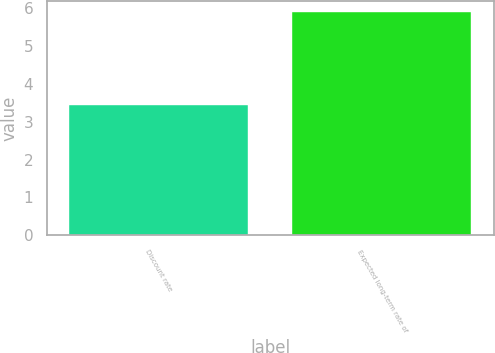Convert chart. <chart><loc_0><loc_0><loc_500><loc_500><bar_chart><fcel>Discount rate<fcel>Expected long-term rate of<nl><fcel>3.43<fcel>5.9<nl></chart> 